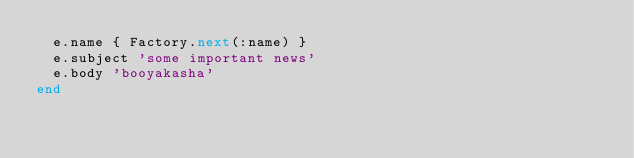<code> <loc_0><loc_0><loc_500><loc_500><_Ruby_>  e.name { Factory.next(:name) }
  e.subject 'some important news'
  e.body 'booyakasha'
end
</code> 